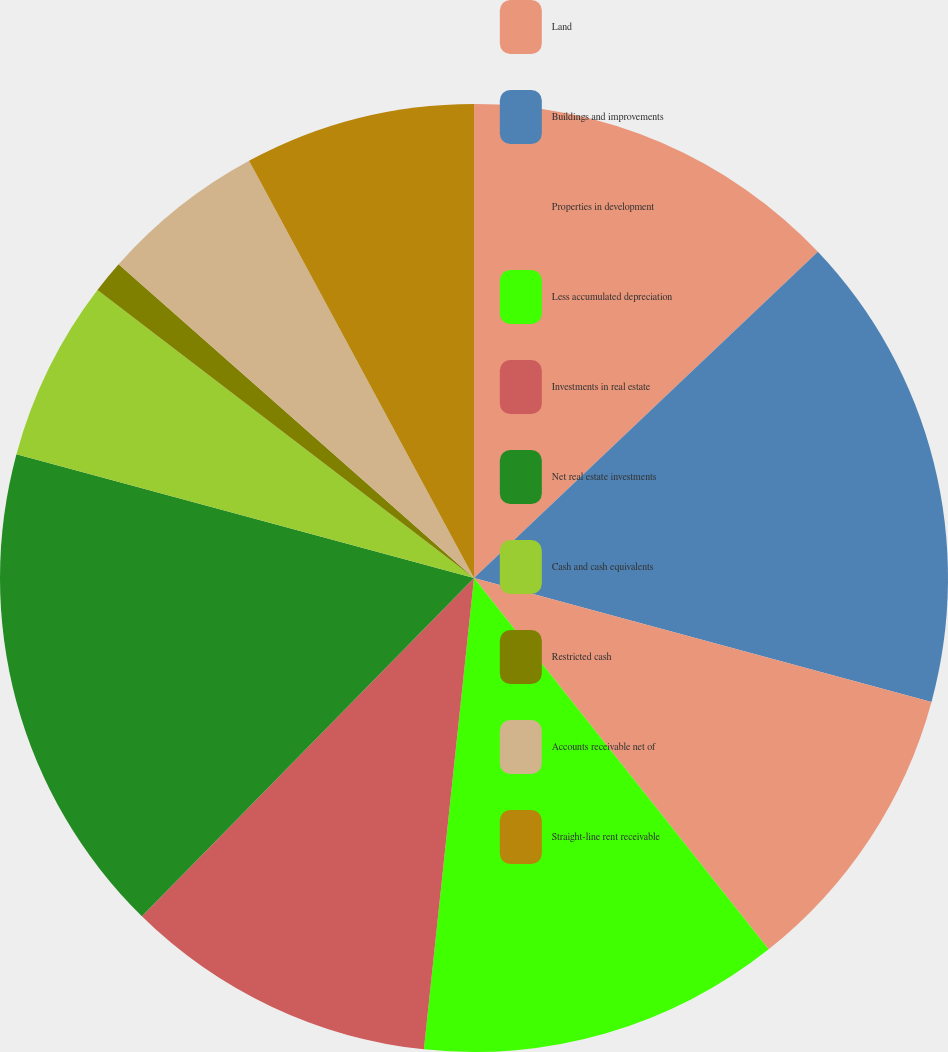<chart> <loc_0><loc_0><loc_500><loc_500><pie_chart><fcel>Land<fcel>Buildings and improvements<fcel>Properties in development<fcel>Less accumulated depreciation<fcel>Investments in real estate<fcel>Net real estate investments<fcel>Cash and cash equivalents<fcel>Restricted cash<fcel>Accounts receivable net of<fcel>Straight-line rent receivable<nl><fcel>12.92%<fcel>16.29%<fcel>10.11%<fcel>12.36%<fcel>10.67%<fcel>16.85%<fcel>6.18%<fcel>1.12%<fcel>5.62%<fcel>7.87%<nl></chart> 